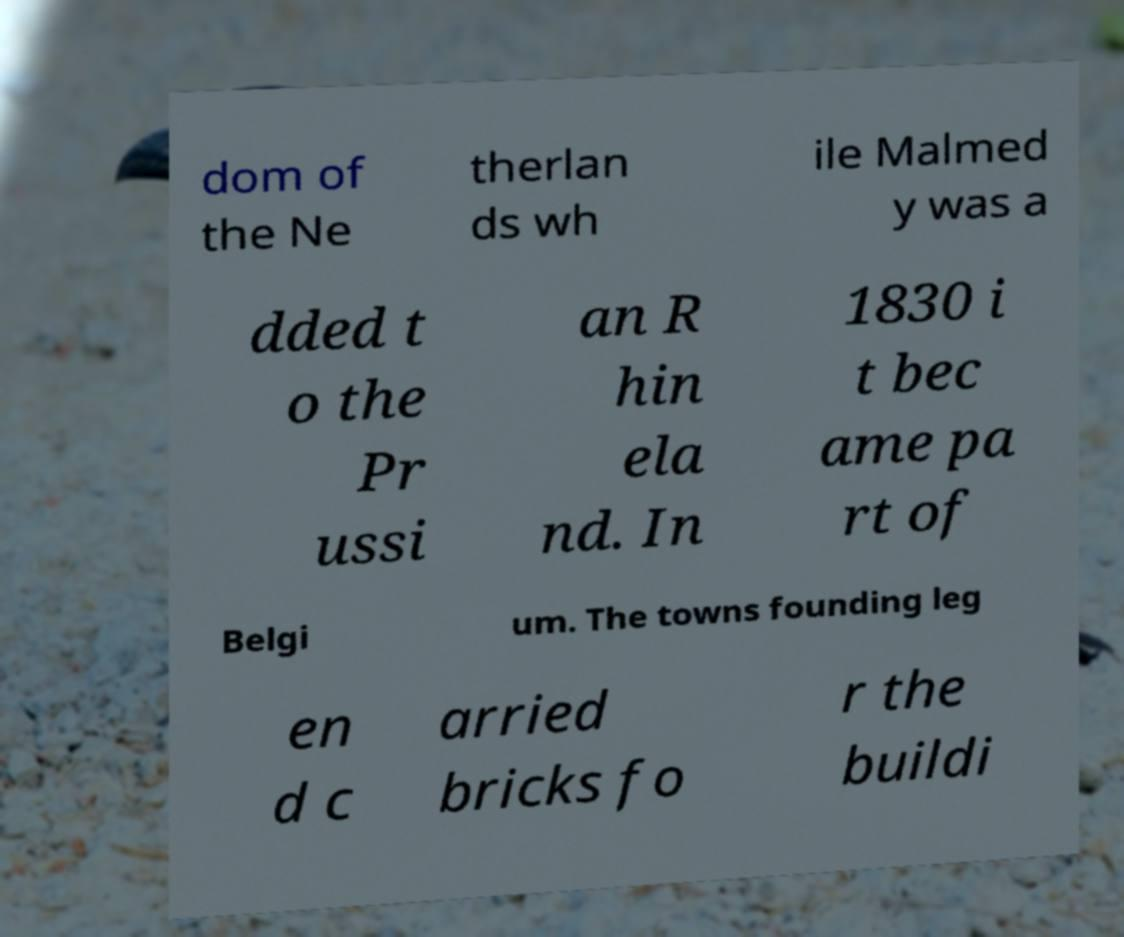I need the written content from this picture converted into text. Can you do that? dom of the Ne therlan ds wh ile Malmed y was a dded t o the Pr ussi an R hin ela nd. In 1830 i t bec ame pa rt of Belgi um. The towns founding leg en d c arried bricks fo r the buildi 